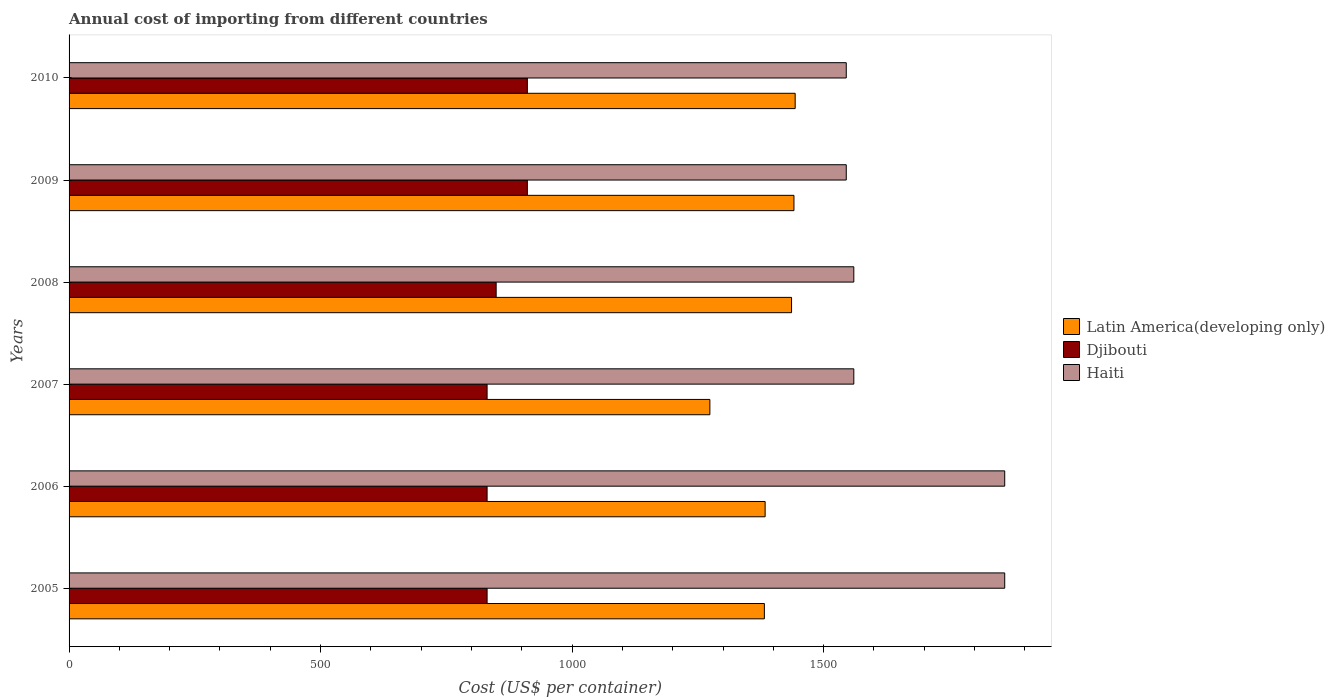How many different coloured bars are there?
Offer a very short reply. 3. How many groups of bars are there?
Ensure brevity in your answer.  6. How many bars are there on the 1st tick from the top?
Your answer should be compact. 3. What is the label of the 3rd group of bars from the top?
Give a very brief answer. 2008. In how many cases, is the number of bars for a given year not equal to the number of legend labels?
Keep it short and to the point. 0. What is the total annual cost of importing in Djibouti in 2006?
Offer a terse response. 831. Across all years, what is the maximum total annual cost of importing in Haiti?
Offer a very short reply. 1860. Across all years, what is the minimum total annual cost of importing in Djibouti?
Your response must be concise. 831. In which year was the total annual cost of importing in Latin America(developing only) minimum?
Ensure brevity in your answer.  2007. What is the total total annual cost of importing in Djibouti in the graph?
Your answer should be compact. 5164. What is the difference between the total annual cost of importing in Haiti in 2008 and that in 2009?
Your answer should be very brief. 15. What is the difference between the total annual cost of importing in Haiti in 2010 and the total annual cost of importing in Latin America(developing only) in 2005?
Keep it short and to the point. 162.78. What is the average total annual cost of importing in Djibouti per year?
Your answer should be very brief. 860.67. In the year 2007, what is the difference between the total annual cost of importing in Haiti and total annual cost of importing in Latin America(developing only)?
Provide a succinct answer. 286.13. In how many years, is the total annual cost of importing in Latin America(developing only) greater than 300 US$?
Provide a succinct answer. 6. What is the ratio of the total annual cost of importing in Haiti in 2008 to that in 2009?
Ensure brevity in your answer.  1.01. What is the difference between the highest and the lowest total annual cost of importing in Haiti?
Your response must be concise. 315. In how many years, is the total annual cost of importing in Latin America(developing only) greater than the average total annual cost of importing in Latin America(developing only) taken over all years?
Offer a terse response. 3. What does the 2nd bar from the top in 2007 represents?
Ensure brevity in your answer.  Djibouti. What does the 2nd bar from the bottom in 2005 represents?
Your response must be concise. Djibouti. Is it the case that in every year, the sum of the total annual cost of importing in Djibouti and total annual cost of importing in Haiti is greater than the total annual cost of importing in Latin America(developing only)?
Give a very brief answer. Yes. How many bars are there?
Keep it short and to the point. 18. Are the values on the major ticks of X-axis written in scientific E-notation?
Give a very brief answer. No. Does the graph contain any zero values?
Ensure brevity in your answer.  No. Does the graph contain grids?
Ensure brevity in your answer.  No. How are the legend labels stacked?
Keep it short and to the point. Vertical. What is the title of the graph?
Offer a terse response. Annual cost of importing from different countries. Does "High income" appear as one of the legend labels in the graph?
Keep it short and to the point. No. What is the label or title of the X-axis?
Provide a succinct answer. Cost (US$ per container). What is the Cost (US$ per container) in Latin America(developing only) in 2005?
Keep it short and to the point. 1382.22. What is the Cost (US$ per container) of Djibouti in 2005?
Give a very brief answer. 831. What is the Cost (US$ per container) in Haiti in 2005?
Provide a short and direct response. 1860. What is the Cost (US$ per container) of Latin America(developing only) in 2006?
Offer a very short reply. 1383.7. What is the Cost (US$ per container) of Djibouti in 2006?
Give a very brief answer. 831. What is the Cost (US$ per container) of Haiti in 2006?
Your answer should be compact. 1860. What is the Cost (US$ per container) of Latin America(developing only) in 2007?
Your answer should be very brief. 1273.87. What is the Cost (US$ per container) of Djibouti in 2007?
Your response must be concise. 831. What is the Cost (US$ per container) in Haiti in 2007?
Provide a succinct answer. 1560. What is the Cost (US$ per container) in Latin America(developing only) in 2008?
Keep it short and to the point. 1436.22. What is the Cost (US$ per container) in Djibouti in 2008?
Keep it short and to the point. 849. What is the Cost (US$ per container) of Haiti in 2008?
Your answer should be very brief. 1560. What is the Cost (US$ per container) in Latin America(developing only) in 2009?
Make the answer very short. 1441. What is the Cost (US$ per container) of Djibouti in 2009?
Offer a very short reply. 911. What is the Cost (US$ per container) of Haiti in 2009?
Offer a very short reply. 1545. What is the Cost (US$ per container) of Latin America(developing only) in 2010?
Provide a short and direct response. 1443.43. What is the Cost (US$ per container) in Djibouti in 2010?
Keep it short and to the point. 911. What is the Cost (US$ per container) in Haiti in 2010?
Your answer should be very brief. 1545. Across all years, what is the maximum Cost (US$ per container) in Latin America(developing only)?
Make the answer very short. 1443.43. Across all years, what is the maximum Cost (US$ per container) of Djibouti?
Ensure brevity in your answer.  911. Across all years, what is the maximum Cost (US$ per container) in Haiti?
Provide a succinct answer. 1860. Across all years, what is the minimum Cost (US$ per container) in Latin America(developing only)?
Make the answer very short. 1273.87. Across all years, what is the minimum Cost (US$ per container) of Djibouti?
Provide a short and direct response. 831. Across all years, what is the minimum Cost (US$ per container) of Haiti?
Keep it short and to the point. 1545. What is the total Cost (US$ per container) of Latin America(developing only) in the graph?
Give a very brief answer. 8360.43. What is the total Cost (US$ per container) in Djibouti in the graph?
Provide a short and direct response. 5164. What is the total Cost (US$ per container) in Haiti in the graph?
Provide a short and direct response. 9930. What is the difference between the Cost (US$ per container) in Latin America(developing only) in 2005 and that in 2006?
Offer a terse response. -1.48. What is the difference between the Cost (US$ per container) of Djibouti in 2005 and that in 2006?
Give a very brief answer. 0. What is the difference between the Cost (US$ per container) in Latin America(developing only) in 2005 and that in 2007?
Provide a succinct answer. 108.35. What is the difference between the Cost (US$ per container) of Djibouti in 2005 and that in 2007?
Give a very brief answer. 0. What is the difference between the Cost (US$ per container) in Haiti in 2005 and that in 2007?
Your answer should be very brief. 300. What is the difference between the Cost (US$ per container) of Latin America(developing only) in 2005 and that in 2008?
Ensure brevity in your answer.  -54. What is the difference between the Cost (US$ per container) in Djibouti in 2005 and that in 2008?
Provide a succinct answer. -18. What is the difference between the Cost (US$ per container) of Haiti in 2005 and that in 2008?
Offer a very short reply. 300. What is the difference between the Cost (US$ per container) in Latin America(developing only) in 2005 and that in 2009?
Your answer should be compact. -58.78. What is the difference between the Cost (US$ per container) in Djibouti in 2005 and that in 2009?
Offer a terse response. -80. What is the difference between the Cost (US$ per container) of Haiti in 2005 and that in 2009?
Provide a short and direct response. 315. What is the difference between the Cost (US$ per container) in Latin America(developing only) in 2005 and that in 2010?
Provide a short and direct response. -61.22. What is the difference between the Cost (US$ per container) of Djibouti in 2005 and that in 2010?
Keep it short and to the point. -80. What is the difference between the Cost (US$ per container) in Haiti in 2005 and that in 2010?
Your answer should be very brief. 315. What is the difference between the Cost (US$ per container) of Latin America(developing only) in 2006 and that in 2007?
Your answer should be very brief. 109.83. What is the difference between the Cost (US$ per container) in Haiti in 2006 and that in 2007?
Offer a very short reply. 300. What is the difference between the Cost (US$ per container) of Latin America(developing only) in 2006 and that in 2008?
Keep it short and to the point. -52.52. What is the difference between the Cost (US$ per container) of Haiti in 2006 and that in 2008?
Offer a very short reply. 300. What is the difference between the Cost (US$ per container) of Latin America(developing only) in 2006 and that in 2009?
Provide a succinct answer. -57.3. What is the difference between the Cost (US$ per container) in Djibouti in 2006 and that in 2009?
Offer a very short reply. -80. What is the difference between the Cost (US$ per container) in Haiti in 2006 and that in 2009?
Give a very brief answer. 315. What is the difference between the Cost (US$ per container) in Latin America(developing only) in 2006 and that in 2010?
Give a very brief answer. -59.74. What is the difference between the Cost (US$ per container) of Djibouti in 2006 and that in 2010?
Offer a terse response. -80. What is the difference between the Cost (US$ per container) in Haiti in 2006 and that in 2010?
Your answer should be very brief. 315. What is the difference between the Cost (US$ per container) in Latin America(developing only) in 2007 and that in 2008?
Your answer should be compact. -162.35. What is the difference between the Cost (US$ per container) of Haiti in 2007 and that in 2008?
Offer a terse response. 0. What is the difference between the Cost (US$ per container) in Latin America(developing only) in 2007 and that in 2009?
Your answer should be compact. -167.13. What is the difference between the Cost (US$ per container) in Djibouti in 2007 and that in 2009?
Ensure brevity in your answer.  -80. What is the difference between the Cost (US$ per container) of Latin America(developing only) in 2007 and that in 2010?
Offer a very short reply. -169.57. What is the difference between the Cost (US$ per container) in Djibouti in 2007 and that in 2010?
Offer a very short reply. -80. What is the difference between the Cost (US$ per container) of Haiti in 2007 and that in 2010?
Your response must be concise. 15. What is the difference between the Cost (US$ per container) of Latin America(developing only) in 2008 and that in 2009?
Ensure brevity in your answer.  -4.78. What is the difference between the Cost (US$ per container) of Djibouti in 2008 and that in 2009?
Your answer should be very brief. -62. What is the difference between the Cost (US$ per container) in Haiti in 2008 and that in 2009?
Ensure brevity in your answer.  15. What is the difference between the Cost (US$ per container) of Latin America(developing only) in 2008 and that in 2010?
Your response must be concise. -7.22. What is the difference between the Cost (US$ per container) in Djibouti in 2008 and that in 2010?
Provide a short and direct response. -62. What is the difference between the Cost (US$ per container) of Haiti in 2008 and that in 2010?
Ensure brevity in your answer.  15. What is the difference between the Cost (US$ per container) of Latin America(developing only) in 2009 and that in 2010?
Your response must be concise. -2.43. What is the difference between the Cost (US$ per container) in Haiti in 2009 and that in 2010?
Your answer should be very brief. 0. What is the difference between the Cost (US$ per container) in Latin America(developing only) in 2005 and the Cost (US$ per container) in Djibouti in 2006?
Your response must be concise. 551.22. What is the difference between the Cost (US$ per container) in Latin America(developing only) in 2005 and the Cost (US$ per container) in Haiti in 2006?
Your answer should be very brief. -477.78. What is the difference between the Cost (US$ per container) of Djibouti in 2005 and the Cost (US$ per container) of Haiti in 2006?
Your answer should be very brief. -1029. What is the difference between the Cost (US$ per container) of Latin America(developing only) in 2005 and the Cost (US$ per container) of Djibouti in 2007?
Offer a terse response. 551.22. What is the difference between the Cost (US$ per container) of Latin America(developing only) in 2005 and the Cost (US$ per container) of Haiti in 2007?
Make the answer very short. -177.78. What is the difference between the Cost (US$ per container) of Djibouti in 2005 and the Cost (US$ per container) of Haiti in 2007?
Your answer should be very brief. -729. What is the difference between the Cost (US$ per container) in Latin America(developing only) in 2005 and the Cost (US$ per container) in Djibouti in 2008?
Give a very brief answer. 533.22. What is the difference between the Cost (US$ per container) of Latin America(developing only) in 2005 and the Cost (US$ per container) of Haiti in 2008?
Offer a terse response. -177.78. What is the difference between the Cost (US$ per container) in Djibouti in 2005 and the Cost (US$ per container) in Haiti in 2008?
Offer a very short reply. -729. What is the difference between the Cost (US$ per container) in Latin America(developing only) in 2005 and the Cost (US$ per container) in Djibouti in 2009?
Make the answer very short. 471.22. What is the difference between the Cost (US$ per container) in Latin America(developing only) in 2005 and the Cost (US$ per container) in Haiti in 2009?
Give a very brief answer. -162.78. What is the difference between the Cost (US$ per container) of Djibouti in 2005 and the Cost (US$ per container) of Haiti in 2009?
Give a very brief answer. -714. What is the difference between the Cost (US$ per container) of Latin America(developing only) in 2005 and the Cost (US$ per container) of Djibouti in 2010?
Provide a succinct answer. 471.22. What is the difference between the Cost (US$ per container) of Latin America(developing only) in 2005 and the Cost (US$ per container) of Haiti in 2010?
Your response must be concise. -162.78. What is the difference between the Cost (US$ per container) of Djibouti in 2005 and the Cost (US$ per container) of Haiti in 2010?
Your response must be concise. -714. What is the difference between the Cost (US$ per container) of Latin America(developing only) in 2006 and the Cost (US$ per container) of Djibouti in 2007?
Make the answer very short. 552.7. What is the difference between the Cost (US$ per container) in Latin America(developing only) in 2006 and the Cost (US$ per container) in Haiti in 2007?
Keep it short and to the point. -176.3. What is the difference between the Cost (US$ per container) of Djibouti in 2006 and the Cost (US$ per container) of Haiti in 2007?
Keep it short and to the point. -729. What is the difference between the Cost (US$ per container) of Latin America(developing only) in 2006 and the Cost (US$ per container) of Djibouti in 2008?
Give a very brief answer. 534.7. What is the difference between the Cost (US$ per container) in Latin America(developing only) in 2006 and the Cost (US$ per container) in Haiti in 2008?
Provide a short and direct response. -176.3. What is the difference between the Cost (US$ per container) of Djibouti in 2006 and the Cost (US$ per container) of Haiti in 2008?
Your answer should be very brief. -729. What is the difference between the Cost (US$ per container) of Latin America(developing only) in 2006 and the Cost (US$ per container) of Djibouti in 2009?
Ensure brevity in your answer.  472.7. What is the difference between the Cost (US$ per container) of Latin America(developing only) in 2006 and the Cost (US$ per container) of Haiti in 2009?
Provide a short and direct response. -161.3. What is the difference between the Cost (US$ per container) in Djibouti in 2006 and the Cost (US$ per container) in Haiti in 2009?
Offer a very short reply. -714. What is the difference between the Cost (US$ per container) in Latin America(developing only) in 2006 and the Cost (US$ per container) in Djibouti in 2010?
Your answer should be very brief. 472.7. What is the difference between the Cost (US$ per container) of Latin America(developing only) in 2006 and the Cost (US$ per container) of Haiti in 2010?
Your answer should be compact. -161.3. What is the difference between the Cost (US$ per container) of Djibouti in 2006 and the Cost (US$ per container) of Haiti in 2010?
Make the answer very short. -714. What is the difference between the Cost (US$ per container) in Latin America(developing only) in 2007 and the Cost (US$ per container) in Djibouti in 2008?
Ensure brevity in your answer.  424.87. What is the difference between the Cost (US$ per container) in Latin America(developing only) in 2007 and the Cost (US$ per container) in Haiti in 2008?
Provide a succinct answer. -286.13. What is the difference between the Cost (US$ per container) in Djibouti in 2007 and the Cost (US$ per container) in Haiti in 2008?
Offer a terse response. -729. What is the difference between the Cost (US$ per container) in Latin America(developing only) in 2007 and the Cost (US$ per container) in Djibouti in 2009?
Keep it short and to the point. 362.87. What is the difference between the Cost (US$ per container) in Latin America(developing only) in 2007 and the Cost (US$ per container) in Haiti in 2009?
Provide a succinct answer. -271.13. What is the difference between the Cost (US$ per container) in Djibouti in 2007 and the Cost (US$ per container) in Haiti in 2009?
Provide a succinct answer. -714. What is the difference between the Cost (US$ per container) of Latin America(developing only) in 2007 and the Cost (US$ per container) of Djibouti in 2010?
Offer a terse response. 362.87. What is the difference between the Cost (US$ per container) of Latin America(developing only) in 2007 and the Cost (US$ per container) of Haiti in 2010?
Ensure brevity in your answer.  -271.13. What is the difference between the Cost (US$ per container) of Djibouti in 2007 and the Cost (US$ per container) of Haiti in 2010?
Give a very brief answer. -714. What is the difference between the Cost (US$ per container) of Latin America(developing only) in 2008 and the Cost (US$ per container) of Djibouti in 2009?
Your answer should be very brief. 525.22. What is the difference between the Cost (US$ per container) of Latin America(developing only) in 2008 and the Cost (US$ per container) of Haiti in 2009?
Provide a short and direct response. -108.78. What is the difference between the Cost (US$ per container) of Djibouti in 2008 and the Cost (US$ per container) of Haiti in 2009?
Your response must be concise. -696. What is the difference between the Cost (US$ per container) of Latin America(developing only) in 2008 and the Cost (US$ per container) of Djibouti in 2010?
Your response must be concise. 525.22. What is the difference between the Cost (US$ per container) in Latin America(developing only) in 2008 and the Cost (US$ per container) in Haiti in 2010?
Ensure brevity in your answer.  -108.78. What is the difference between the Cost (US$ per container) in Djibouti in 2008 and the Cost (US$ per container) in Haiti in 2010?
Provide a short and direct response. -696. What is the difference between the Cost (US$ per container) in Latin America(developing only) in 2009 and the Cost (US$ per container) in Djibouti in 2010?
Offer a terse response. 530. What is the difference between the Cost (US$ per container) in Latin America(developing only) in 2009 and the Cost (US$ per container) in Haiti in 2010?
Give a very brief answer. -104. What is the difference between the Cost (US$ per container) of Djibouti in 2009 and the Cost (US$ per container) of Haiti in 2010?
Your answer should be compact. -634. What is the average Cost (US$ per container) of Latin America(developing only) per year?
Your answer should be very brief. 1393.41. What is the average Cost (US$ per container) of Djibouti per year?
Your answer should be very brief. 860.67. What is the average Cost (US$ per container) of Haiti per year?
Make the answer very short. 1655. In the year 2005, what is the difference between the Cost (US$ per container) in Latin America(developing only) and Cost (US$ per container) in Djibouti?
Offer a terse response. 551.22. In the year 2005, what is the difference between the Cost (US$ per container) in Latin America(developing only) and Cost (US$ per container) in Haiti?
Ensure brevity in your answer.  -477.78. In the year 2005, what is the difference between the Cost (US$ per container) of Djibouti and Cost (US$ per container) of Haiti?
Offer a terse response. -1029. In the year 2006, what is the difference between the Cost (US$ per container) of Latin America(developing only) and Cost (US$ per container) of Djibouti?
Provide a short and direct response. 552.7. In the year 2006, what is the difference between the Cost (US$ per container) in Latin America(developing only) and Cost (US$ per container) in Haiti?
Offer a terse response. -476.3. In the year 2006, what is the difference between the Cost (US$ per container) in Djibouti and Cost (US$ per container) in Haiti?
Offer a very short reply. -1029. In the year 2007, what is the difference between the Cost (US$ per container) in Latin America(developing only) and Cost (US$ per container) in Djibouti?
Provide a succinct answer. 442.87. In the year 2007, what is the difference between the Cost (US$ per container) of Latin America(developing only) and Cost (US$ per container) of Haiti?
Keep it short and to the point. -286.13. In the year 2007, what is the difference between the Cost (US$ per container) of Djibouti and Cost (US$ per container) of Haiti?
Make the answer very short. -729. In the year 2008, what is the difference between the Cost (US$ per container) in Latin America(developing only) and Cost (US$ per container) in Djibouti?
Provide a succinct answer. 587.22. In the year 2008, what is the difference between the Cost (US$ per container) of Latin America(developing only) and Cost (US$ per container) of Haiti?
Provide a succinct answer. -123.78. In the year 2008, what is the difference between the Cost (US$ per container) of Djibouti and Cost (US$ per container) of Haiti?
Provide a short and direct response. -711. In the year 2009, what is the difference between the Cost (US$ per container) of Latin America(developing only) and Cost (US$ per container) of Djibouti?
Your answer should be compact. 530. In the year 2009, what is the difference between the Cost (US$ per container) in Latin America(developing only) and Cost (US$ per container) in Haiti?
Make the answer very short. -104. In the year 2009, what is the difference between the Cost (US$ per container) in Djibouti and Cost (US$ per container) in Haiti?
Your answer should be compact. -634. In the year 2010, what is the difference between the Cost (US$ per container) in Latin America(developing only) and Cost (US$ per container) in Djibouti?
Your answer should be very brief. 532.43. In the year 2010, what is the difference between the Cost (US$ per container) in Latin America(developing only) and Cost (US$ per container) in Haiti?
Offer a very short reply. -101.57. In the year 2010, what is the difference between the Cost (US$ per container) in Djibouti and Cost (US$ per container) in Haiti?
Your answer should be compact. -634. What is the ratio of the Cost (US$ per container) in Djibouti in 2005 to that in 2006?
Make the answer very short. 1. What is the ratio of the Cost (US$ per container) in Latin America(developing only) in 2005 to that in 2007?
Keep it short and to the point. 1.09. What is the ratio of the Cost (US$ per container) in Haiti in 2005 to that in 2007?
Provide a short and direct response. 1.19. What is the ratio of the Cost (US$ per container) of Latin America(developing only) in 2005 to that in 2008?
Your answer should be compact. 0.96. What is the ratio of the Cost (US$ per container) in Djibouti in 2005 to that in 2008?
Provide a short and direct response. 0.98. What is the ratio of the Cost (US$ per container) in Haiti in 2005 to that in 2008?
Offer a terse response. 1.19. What is the ratio of the Cost (US$ per container) of Latin America(developing only) in 2005 to that in 2009?
Make the answer very short. 0.96. What is the ratio of the Cost (US$ per container) of Djibouti in 2005 to that in 2009?
Your answer should be compact. 0.91. What is the ratio of the Cost (US$ per container) of Haiti in 2005 to that in 2009?
Your response must be concise. 1.2. What is the ratio of the Cost (US$ per container) in Latin America(developing only) in 2005 to that in 2010?
Provide a succinct answer. 0.96. What is the ratio of the Cost (US$ per container) in Djibouti in 2005 to that in 2010?
Your answer should be compact. 0.91. What is the ratio of the Cost (US$ per container) in Haiti in 2005 to that in 2010?
Give a very brief answer. 1.2. What is the ratio of the Cost (US$ per container) in Latin America(developing only) in 2006 to that in 2007?
Keep it short and to the point. 1.09. What is the ratio of the Cost (US$ per container) of Djibouti in 2006 to that in 2007?
Provide a succinct answer. 1. What is the ratio of the Cost (US$ per container) in Haiti in 2006 to that in 2007?
Offer a terse response. 1.19. What is the ratio of the Cost (US$ per container) of Latin America(developing only) in 2006 to that in 2008?
Provide a short and direct response. 0.96. What is the ratio of the Cost (US$ per container) of Djibouti in 2006 to that in 2008?
Keep it short and to the point. 0.98. What is the ratio of the Cost (US$ per container) of Haiti in 2006 to that in 2008?
Give a very brief answer. 1.19. What is the ratio of the Cost (US$ per container) of Latin America(developing only) in 2006 to that in 2009?
Provide a short and direct response. 0.96. What is the ratio of the Cost (US$ per container) in Djibouti in 2006 to that in 2009?
Provide a short and direct response. 0.91. What is the ratio of the Cost (US$ per container) in Haiti in 2006 to that in 2009?
Your answer should be compact. 1.2. What is the ratio of the Cost (US$ per container) in Latin America(developing only) in 2006 to that in 2010?
Keep it short and to the point. 0.96. What is the ratio of the Cost (US$ per container) of Djibouti in 2006 to that in 2010?
Give a very brief answer. 0.91. What is the ratio of the Cost (US$ per container) of Haiti in 2006 to that in 2010?
Make the answer very short. 1.2. What is the ratio of the Cost (US$ per container) of Latin America(developing only) in 2007 to that in 2008?
Offer a terse response. 0.89. What is the ratio of the Cost (US$ per container) of Djibouti in 2007 to that in 2008?
Make the answer very short. 0.98. What is the ratio of the Cost (US$ per container) of Latin America(developing only) in 2007 to that in 2009?
Keep it short and to the point. 0.88. What is the ratio of the Cost (US$ per container) of Djibouti in 2007 to that in 2009?
Offer a terse response. 0.91. What is the ratio of the Cost (US$ per container) in Haiti in 2007 to that in 2009?
Offer a terse response. 1.01. What is the ratio of the Cost (US$ per container) in Latin America(developing only) in 2007 to that in 2010?
Your answer should be compact. 0.88. What is the ratio of the Cost (US$ per container) in Djibouti in 2007 to that in 2010?
Offer a very short reply. 0.91. What is the ratio of the Cost (US$ per container) in Haiti in 2007 to that in 2010?
Your answer should be compact. 1.01. What is the ratio of the Cost (US$ per container) in Latin America(developing only) in 2008 to that in 2009?
Your answer should be compact. 1. What is the ratio of the Cost (US$ per container) of Djibouti in 2008 to that in 2009?
Provide a short and direct response. 0.93. What is the ratio of the Cost (US$ per container) in Haiti in 2008 to that in 2009?
Make the answer very short. 1.01. What is the ratio of the Cost (US$ per container) in Latin America(developing only) in 2008 to that in 2010?
Offer a terse response. 0.99. What is the ratio of the Cost (US$ per container) of Djibouti in 2008 to that in 2010?
Give a very brief answer. 0.93. What is the ratio of the Cost (US$ per container) of Haiti in 2008 to that in 2010?
Provide a succinct answer. 1.01. What is the difference between the highest and the second highest Cost (US$ per container) in Latin America(developing only)?
Make the answer very short. 2.43. What is the difference between the highest and the second highest Cost (US$ per container) in Djibouti?
Offer a terse response. 0. What is the difference between the highest and the second highest Cost (US$ per container) in Haiti?
Make the answer very short. 0. What is the difference between the highest and the lowest Cost (US$ per container) in Latin America(developing only)?
Provide a short and direct response. 169.57. What is the difference between the highest and the lowest Cost (US$ per container) in Haiti?
Offer a very short reply. 315. 